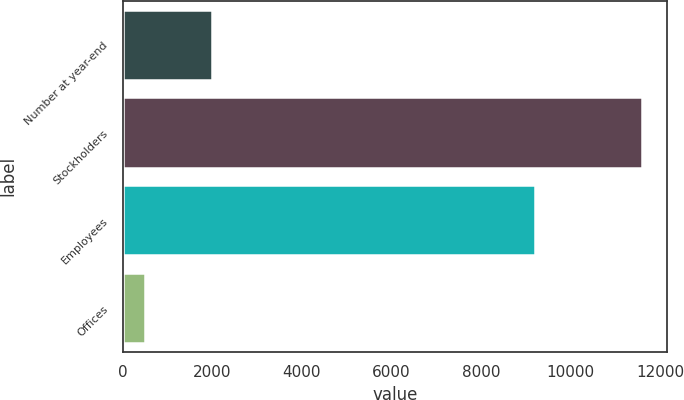Convert chart to OTSL. <chart><loc_0><loc_0><loc_500><loc_500><bar_chart><fcel>Number at year-end<fcel>Stockholders<fcel>Employees<fcel>Offices<nl><fcel>2002<fcel>11587<fcel>9197<fcel>493<nl></chart> 